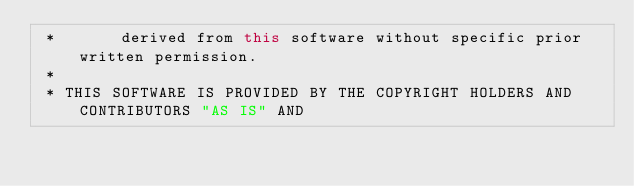<code> <loc_0><loc_0><loc_500><loc_500><_Java_> *       derived from this software without specific prior written permission.
 *
 * THIS SOFTWARE IS PROVIDED BY THE COPYRIGHT HOLDERS AND CONTRIBUTORS "AS IS" AND</code> 